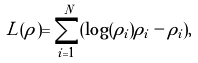<formula> <loc_0><loc_0><loc_500><loc_500>L ( \rho ) = \sum _ { i = 1 } ^ { N } ( \log ( \rho _ { i } ) \rho _ { i } - \rho _ { i } ) ,</formula> 